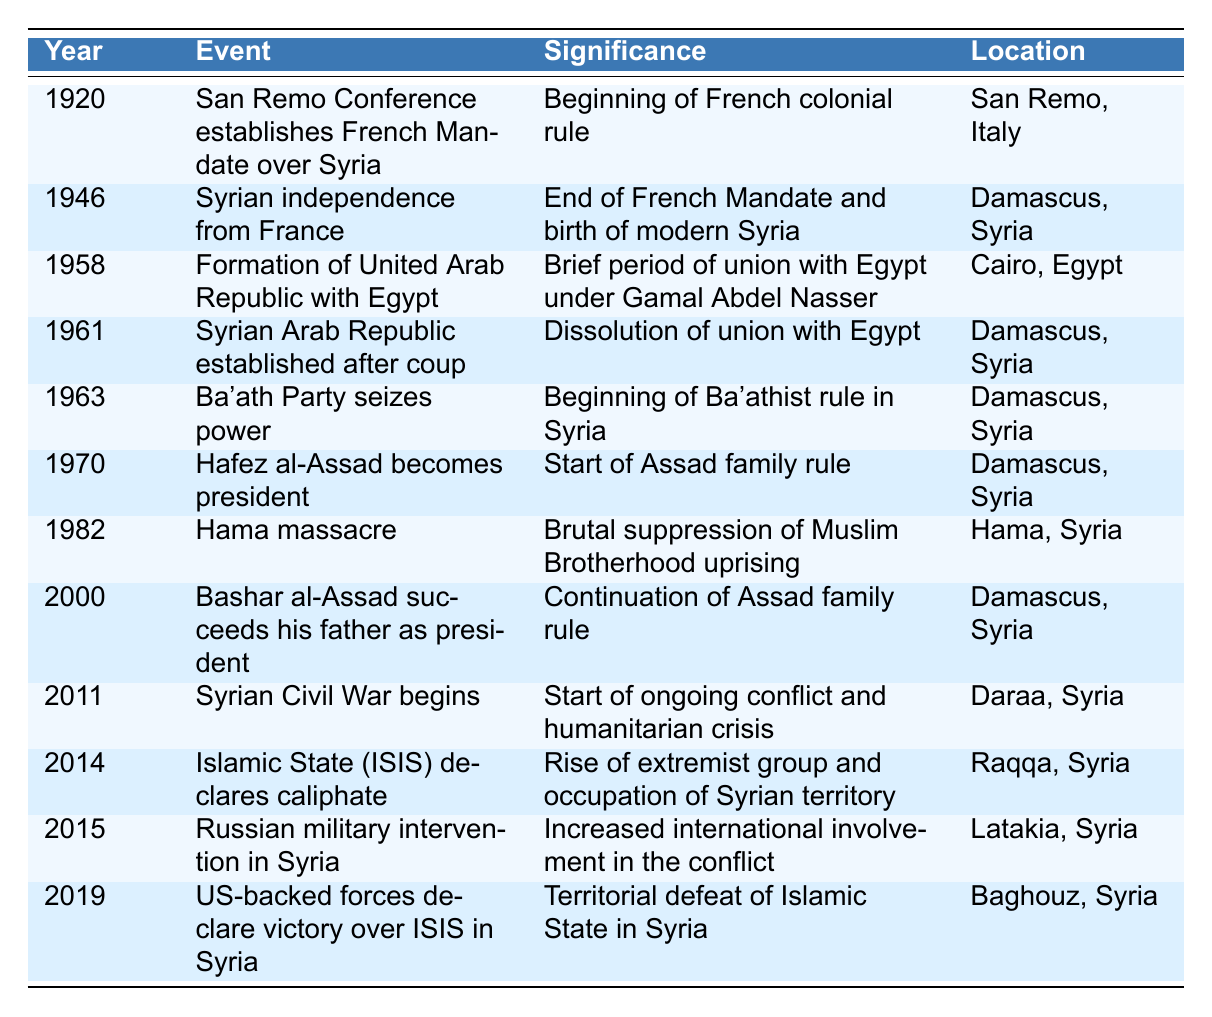What event marked the beginning of French colonial rule in Syria? The table shows that the event in 1920 is the San Remo Conference, which established the French Mandate over Syria.
Answer: San Remo Conference establishes French Mandate over Syria In which year did Syria gain independence from France? By looking at the table, we see that Syria gained independence in 1946, as stated in the relevant event.
Answer: 1946 What was the significance of the Hama massacre in 1982? The table indicates that the Hama massacre was a brutal suppression of the Muslim Brotherhood uprising, which highlights its significance.
Answer: Brutal suppression of Muslim Brotherhood uprising How many years did the United Arab Republic with Egypt last? The formation of the United Arab Republic occurred in 1958, and Syria's dissolution of this union happened in 1961. Thus, it lasted for 3 years (1961 - 1958 = 3).
Answer: 3 years Did the Ba'ath Party's rise to power occur before or after Hafez al-Assad became president? Referring to the table, the Ba'ath Party seized power in 1963, and Hafez al-Assad became president in 1970. Therefore, the Ba'ath Party's rise happened first.
Answer: Before What event occurred in Syria in 2014? The table shows that in 2014, the Islamic State (ISIS) declared a caliphate, marking a significant event during that year.
Answer: Islamic State (ISIS) declares caliphate Which event is associated with the location of Raqqa, Syria? The table indicates that the Islamic State (ISIS) declaring a caliphate in 2014 is associated with Raqqa, marking its significance.
Answer: Islamic State (ISIS) declares caliphate How many events listed in the table occurred in Damascus? By counting the locations for events in the table, we find that there are three events that specifically took place in Damascus: the establishment of the Syrian Arab Republic, the rise of the Ba'ath Party, and Bashar al-Assad succeeding his father.
Answer: 3 events What was the significance of the Russian military intervention in Syria in 2015? According to the table, the significance of the Russian military intervention was the increased international involvement in the conflict, marking a turning point.
Answer: Increased international involvement in the conflict Was the US-backed forces' victory over ISIS in 2019 viewed positively? While the table does not explicitly define opinions, the event is described as a "territorial defeat of Islamic State in Syria," implying a generally positive outcome for the forces involved.
Answer: Yes, positively viewed 